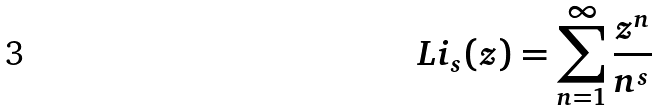<formula> <loc_0><loc_0><loc_500><loc_500>L i _ { s } ( z ) = \sum _ { n = 1 } ^ { \infty } \frac { z ^ { n } } { n ^ { s } }</formula> 